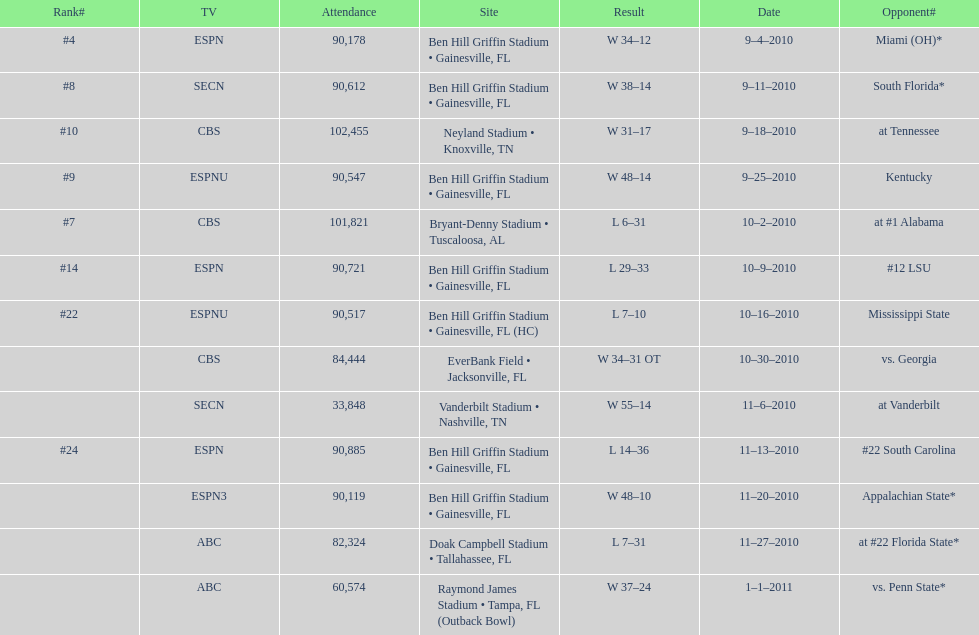What was the most the university of florida won by? 41 points. 